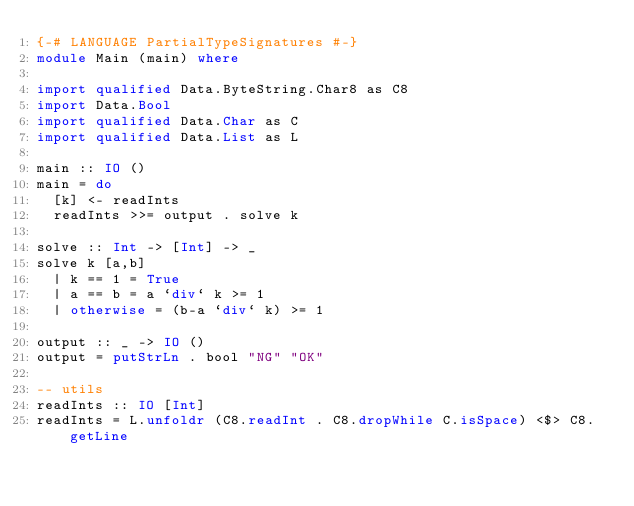<code> <loc_0><loc_0><loc_500><loc_500><_Haskell_>{-# LANGUAGE PartialTypeSignatures #-}
module Main (main) where

import qualified Data.ByteString.Char8 as C8
import Data.Bool
import qualified Data.Char as C
import qualified Data.List as L

main :: IO ()
main = do
  [k] <- readInts
  readInts >>= output . solve k

solve :: Int -> [Int] -> _
solve k [a,b]
  | k == 1 = True
  | a == b = a `div` k >= 1
  | otherwise = (b-a `div` k) >= 1

output :: _ -> IO ()
output = putStrLn . bool "NG" "OK"

-- utils
readInts :: IO [Int]
readInts = L.unfoldr (C8.readInt . C8.dropWhile C.isSpace) <$> C8.getLine</code> 